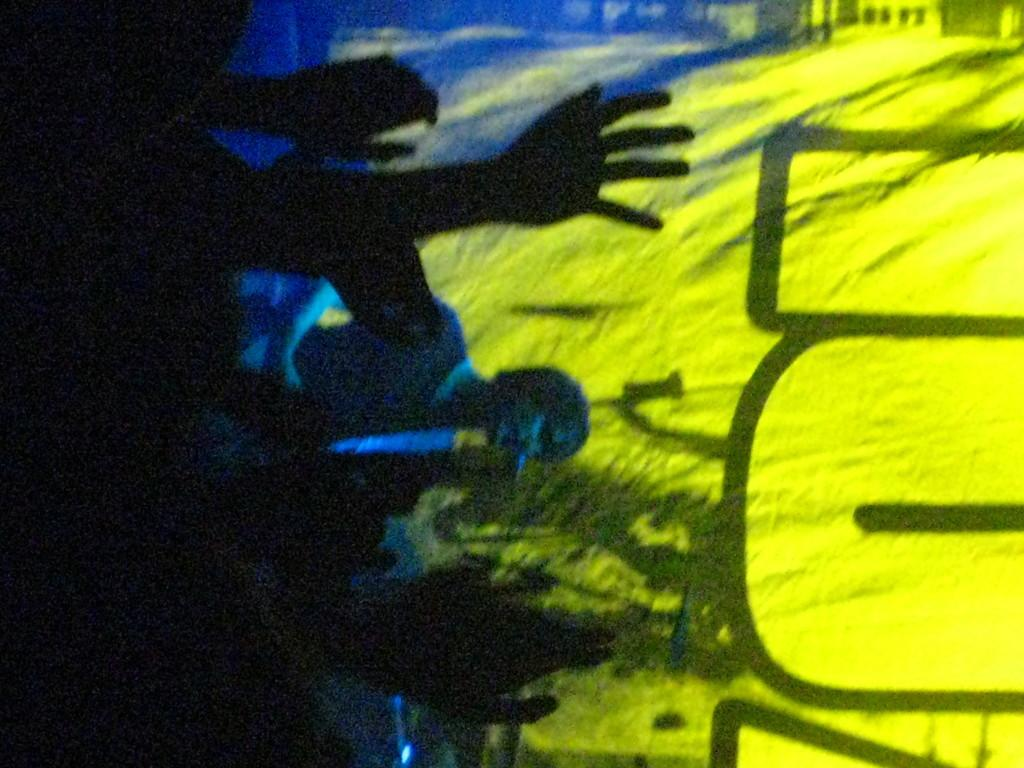What can be seen on the right side of the image? There is a curtain on the right side of the image. What colors are present on the curtain? The curtain has blue and yellow colors. Where are the people located in the image? The people are on the left side of the image. How would you describe the lighting in the image? The people are in a dark environment. What language is being spoken by the people in the image? The image does not provide any information about the language being spoken by the people. Can you see any writing on the curtain in the image? There is no mention of writing on the curtain in the provided facts. 